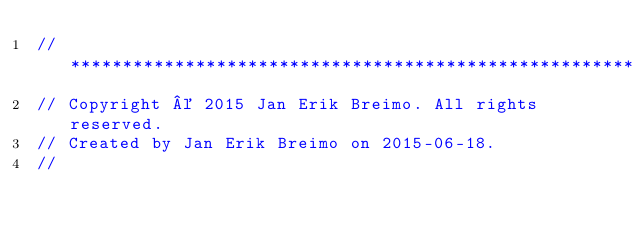Convert code to text. <code><loc_0><loc_0><loc_500><loc_500><_C++_>//****************************************************************************
// Copyright © 2015 Jan Erik Breimo. All rights reserved.
// Created by Jan Erik Breimo on 2015-06-18.
//</code> 